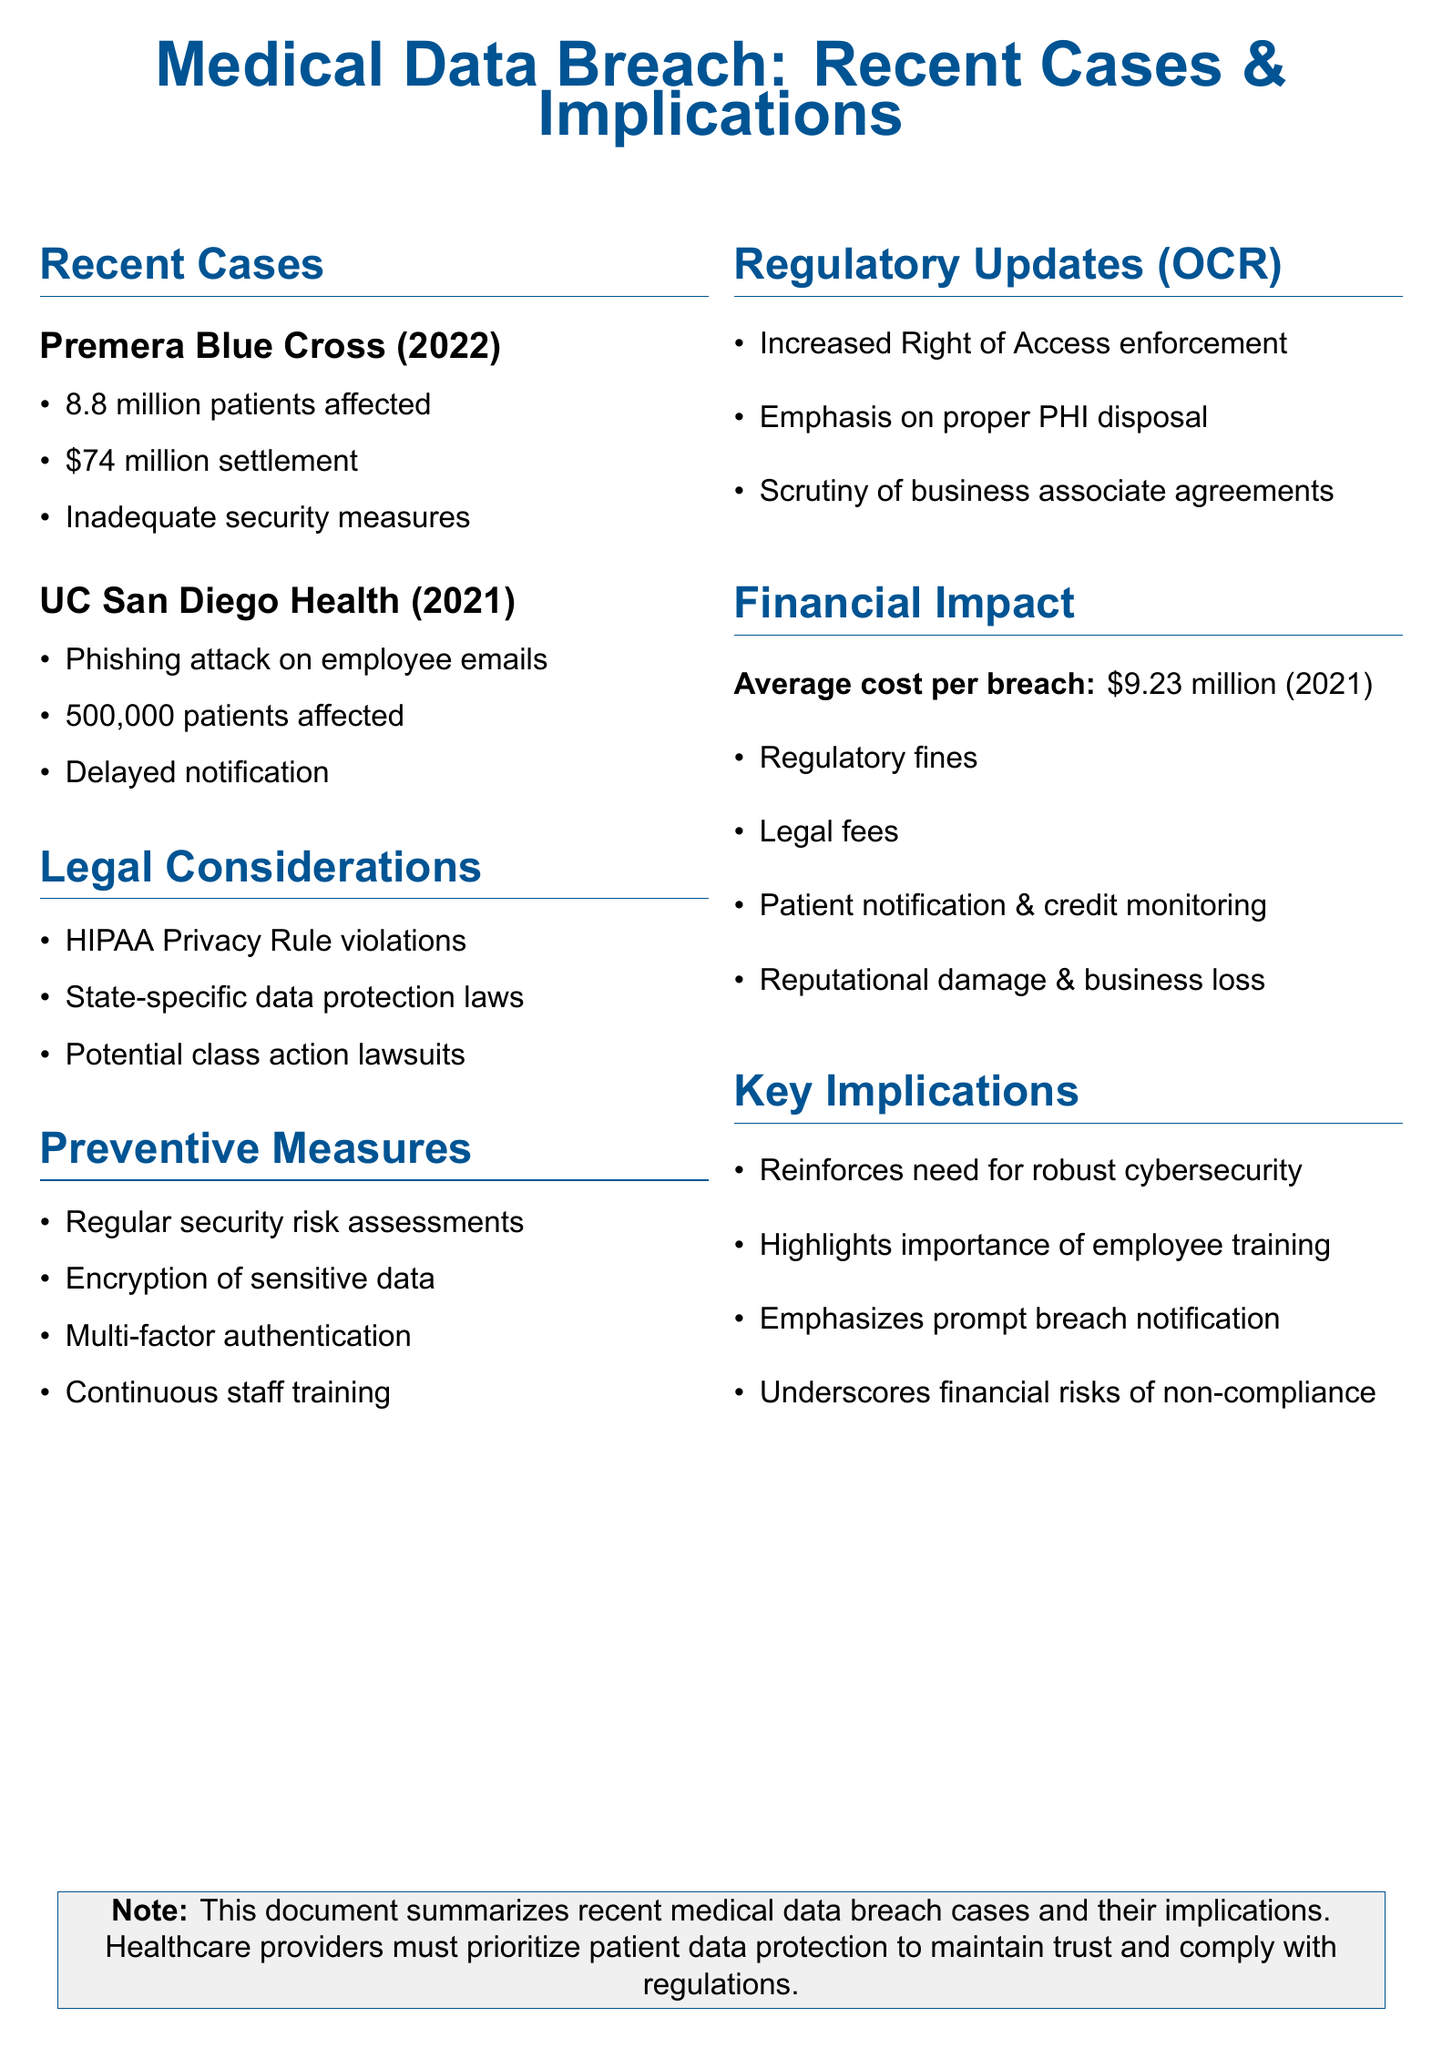What was the settlement amount for Premera Blue Cross? The document states that the settlement amount for Premera Blue Cross was $74 million.
Answer: $74 million How many patients were affected by the University of California San Diego Health data breach? The document specifies that approximately 500,000 patients were affected by the breach.
Answer: 500,000 What is the average cost per breach in the healthcare sector in 2021? According to the document, the average cost per breach in the healthcare sector in 2021 is $9.23 million.
Answer: $9.23 million What key implication is noted for healthcare providers regarding cybersecurity? The document emphasizes that there is a need for robust cybersecurity in healthcare organizations as a key implication.
Answer: Robust cybersecurity What is one of the focus areas of the Office for Civil Rights (OCR)? The document mentions that one focus area of the OCR is the increased enforcement of the Right of Access Initiative.
Answer: Increased Right of Access enforcement What type of attack compromised employee email accounts at UC San Diego Health? The document indicates that a phishing attack compromised employee email accounts at UC San Diego Health.
Answer: Phishing attack What is one preventive measure recommended in the document? The document lists several preventive measures, one of which is the encryption of sensitive data.
Answer: Encryption of sensitive data What legal considerations are mentioned in relation to medical data breaches? The document states that HIPAA Privacy Rule violations are one of the legal considerations mentioned.
Answer: HIPAA Privacy Rule violations 